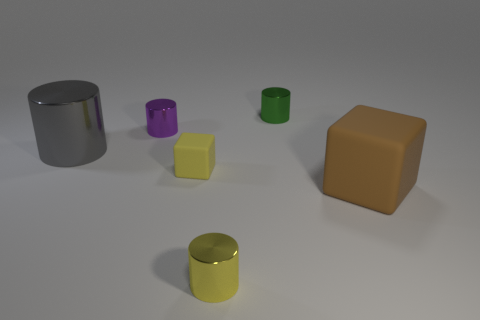What is the shape of the rubber object that is to the right of the cylinder in front of the big gray object?
Keep it short and to the point. Cube. What color is the large thing that is made of the same material as the purple cylinder?
Offer a very short reply. Gray. What shape is the yellow rubber object that is the same size as the purple metal thing?
Offer a very short reply. Cube. What size is the green cylinder?
Ensure brevity in your answer.  Small. There is a block that is in front of the small yellow cube; does it have the same size as the rubber thing that is to the left of the green cylinder?
Make the answer very short. No. There is a small cylinder in front of the rubber thing that is to the left of the green shiny thing; what is its color?
Your answer should be compact. Yellow. What is the material of the yellow cube that is the same size as the yellow cylinder?
Your response must be concise. Rubber. What number of metallic objects are either big gray cylinders or brown cubes?
Provide a short and direct response. 1. What color is the metallic object that is both in front of the purple cylinder and right of the purple metallic thing?
Your answer should be compact. Yellow. There is a small green shiny object; how many small shiny objects are left of it?
Provide a succinct answer. 2. 